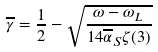Convert formula to latex. <formula><loc_0><loc_0><loc_500><loc_500>\overline { \gamma } = \frac { 1 } { 2 } - \sqrt { \frac { \omega - \omega _ { L } } { 1 4 \overline { \alpha } _ { S } \zeta ( 3 ) } }</formula> 